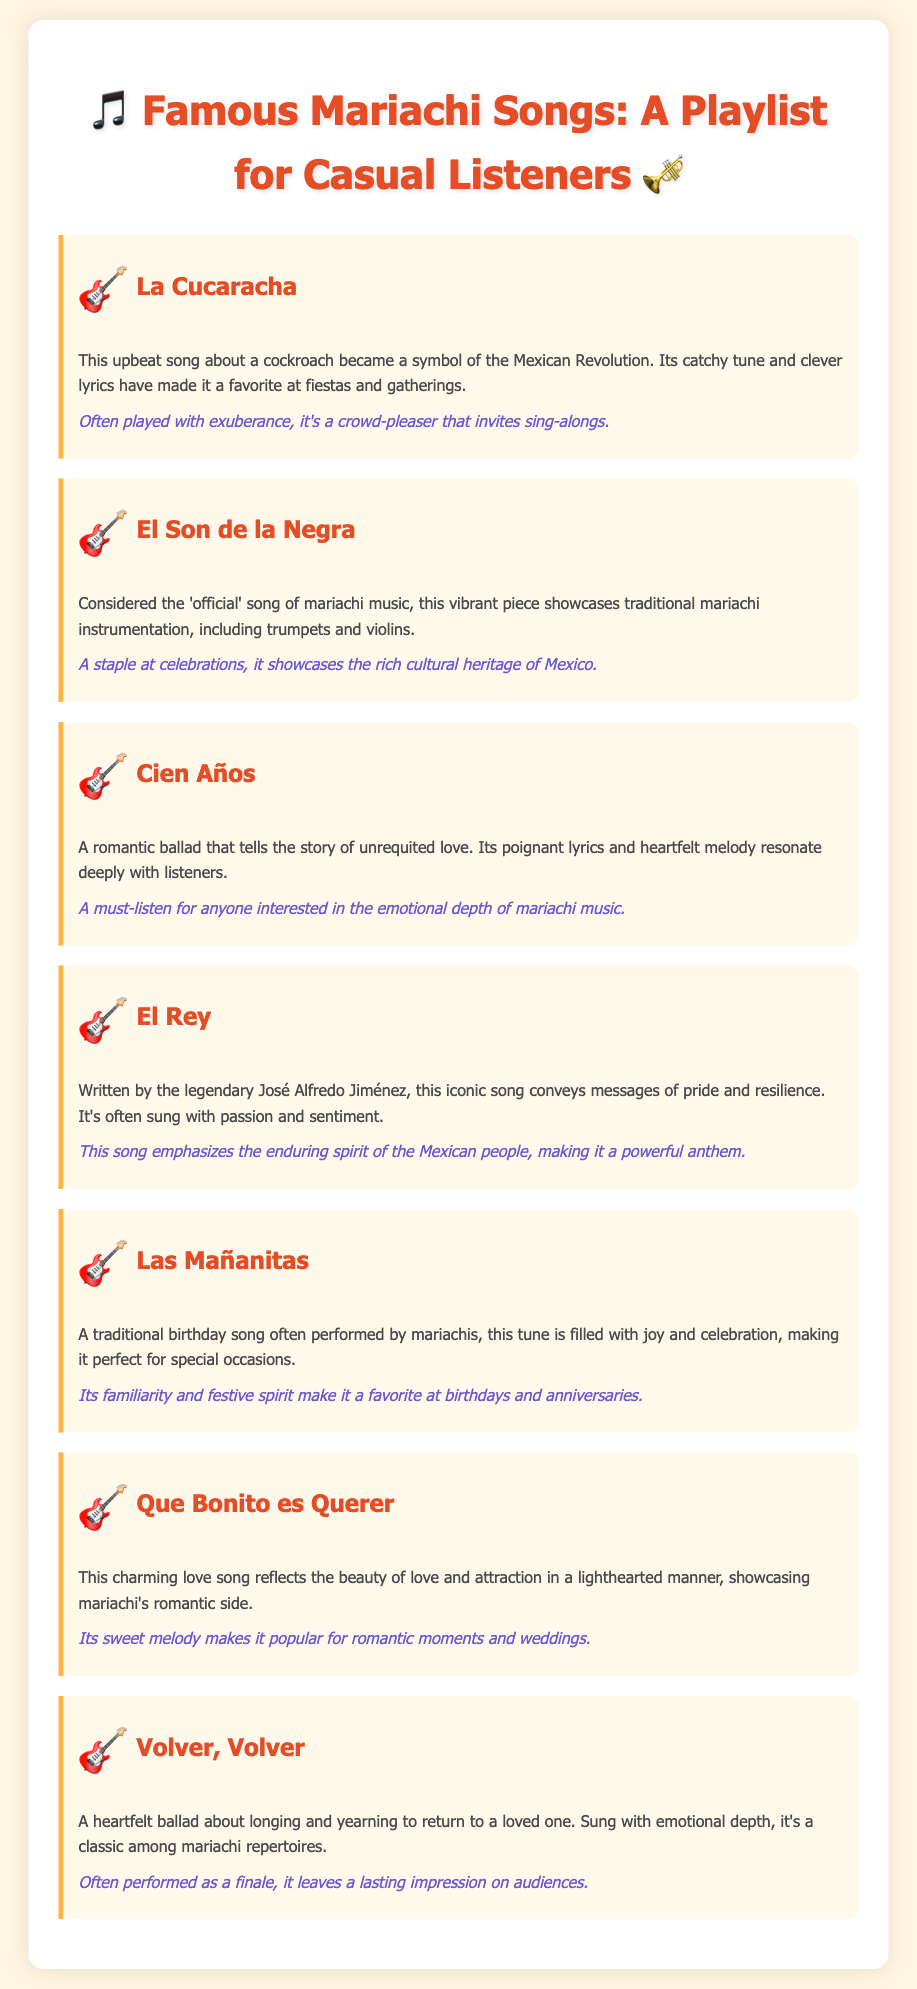What is the title of the document? The title is presented prominently at the top of the document as "Famous Mariachi Songs: A Playlist for Casual Listeners."
Answer: Famous Mariachi Songs: A Playlist for Casual Listeners How many songs are listed in the document? There are seven songs mentioned in the document, as indicated by the individual song sections.
Answer: 7 Which song is considered the 'official' song of mariachi music? The description for "El Son de la Negra" states it is considered the 'official' song of mariachi music.
Answer: El Son de la Negra Who wrote the song "El Rey"? The document mentions that "El Rey" was written by the legendary José Alfredo Jiménez.
Answer: José Alfredo Jiménez What kind of occasions is "Las Mañanitas" typically performed at? The document notes that "Las Mañanitas" is often performed at birthdays and special occasions.
Answer: Birthdays Which song focuses on the theme of unrequited love? "Cien Años" is described as a romantic ballad that tells the story of unrequited love.
Answer: Cien Años What mood does "Que Bonito es Querer" convey? The description highlights that "Que Bonito es Querer" reflects the beauty of love and attraction in a lighthearted manner.
Answer: Lighthearted Which song is often performed as a finale? The document states that "Volver, Volver" is often performed as a finale, leaving a lasting impression.
Answer: Volver, Volver 